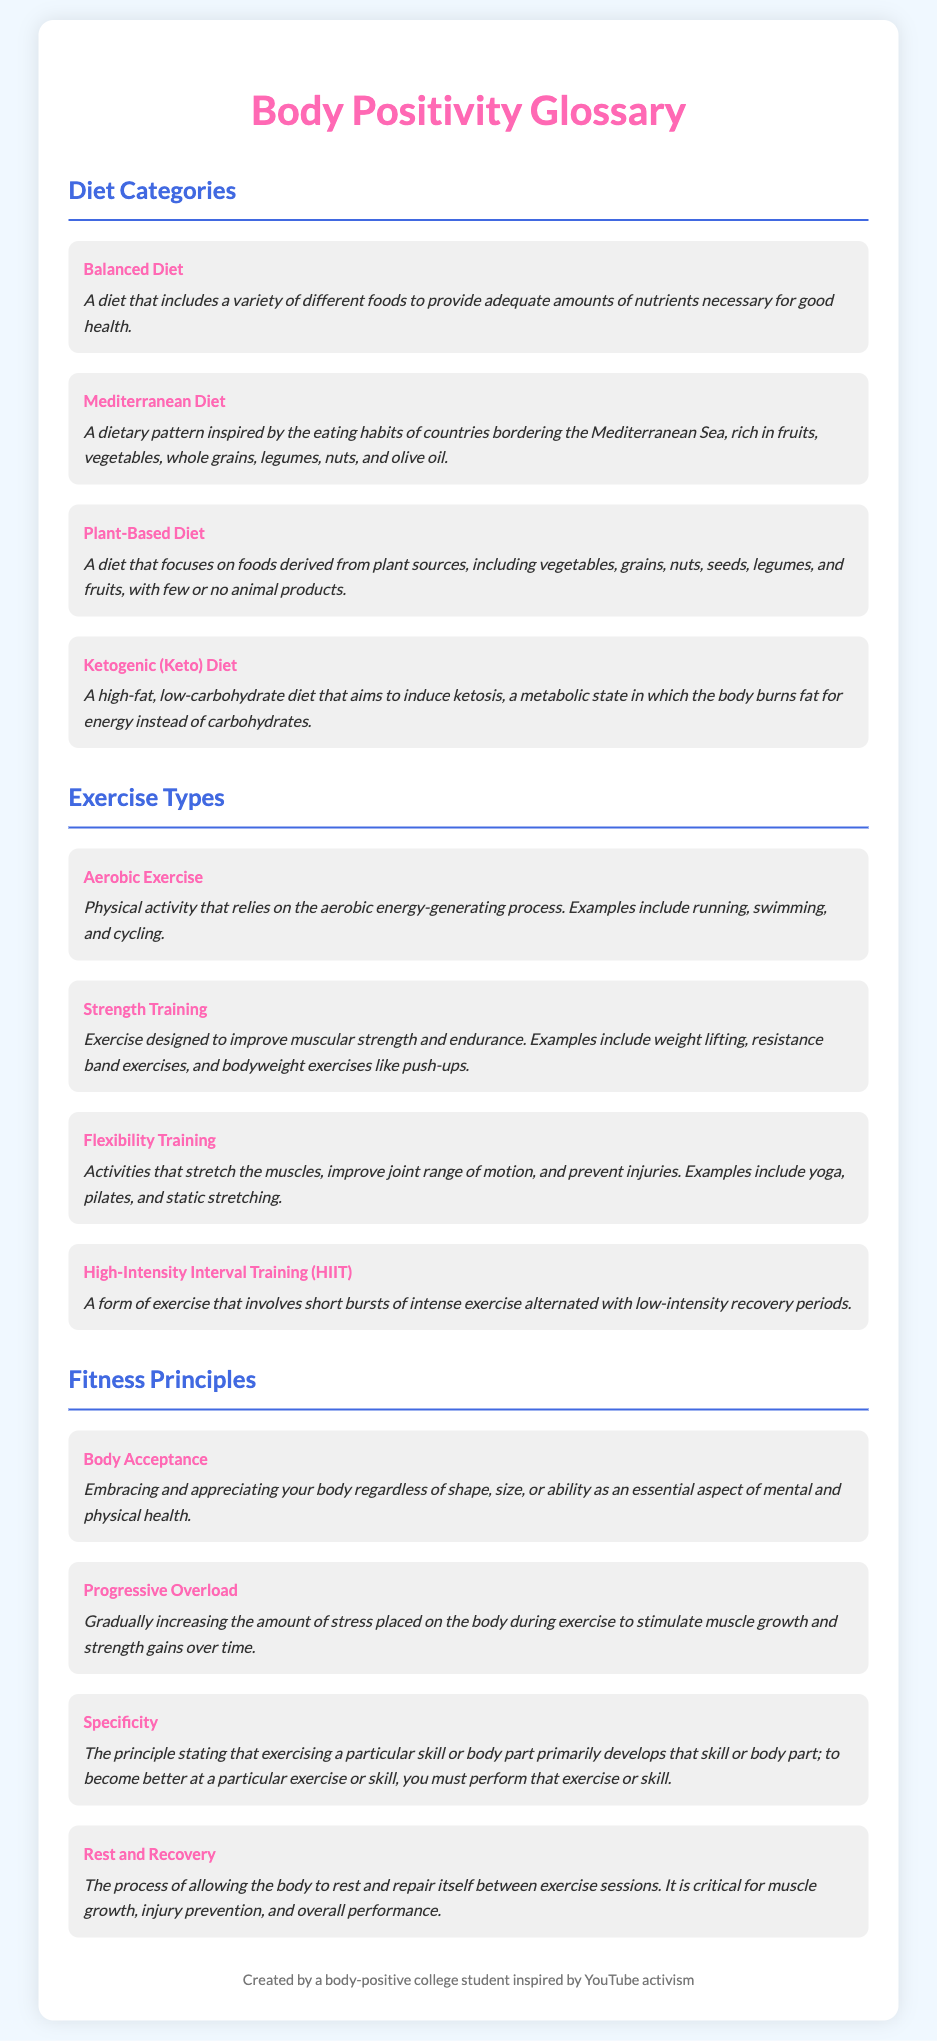what is a Balanced Diet? A Balanced Diet is defined in the document as a variety of different foods to provide adequate amounts of nutrients necessary for good health.
Answer: A variety of different foods what are examples of Aerobic Exercise? The document lists examples of Aerobic Exercise including running, swimming, and cycling.
Answer: running, swimming, cycling what is the purpose of Flexibility Training? The document states that Flexibility Training improves joint range of motion and prevents injuries.
Answer: improve joint range of motion and prevent injuries what is the primary focus of a Plant-Based Diet? The document explains that a Plant-Based Diet focuses on foods derived from plant sources with few or no animal products.
Answer: foods derived from plant sources how does Progressive Overload work? According to the document, Progressive Overload involves gradually increasing the amount of stress placed on the body during exercise to stimulate muscle growth and strength gains.
Answer: gradually increasing the amount of stress what is the main goal of High-Intensity Interval Training (HIIT)? The document indicates that the main goal of HIIT is to involve short bursts of intense exercise alternating with low-intensity recovery periods.
Answer: short bursts of intense exercise what is the definition of Body Acceptance? Body Acceptance is defined in the document as embracing and appreciating your body regardless of shape, size, or ability.
Answer: embracing and appreciating your body what type of exercises improve muscular strength? The document classifies Strength Training as exercise designed to improve muscular strength and endurance.
Answer: Strength Training what does Rest and Recovery contribute to? The document highlights that Rest and Recovery is critical for muscle growth, injury prevention, and overall performance.
Answer: muscle growth, injury prevention, overall performance 